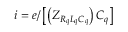Convert formula to latex. <formula><loc_0><loc_0><loc_500><loc_500>i = e / \left [ \left ( Z _ { R _ { q } L _ { q } C _ { q } } \right ) C _ { q } \right ]</formula> 